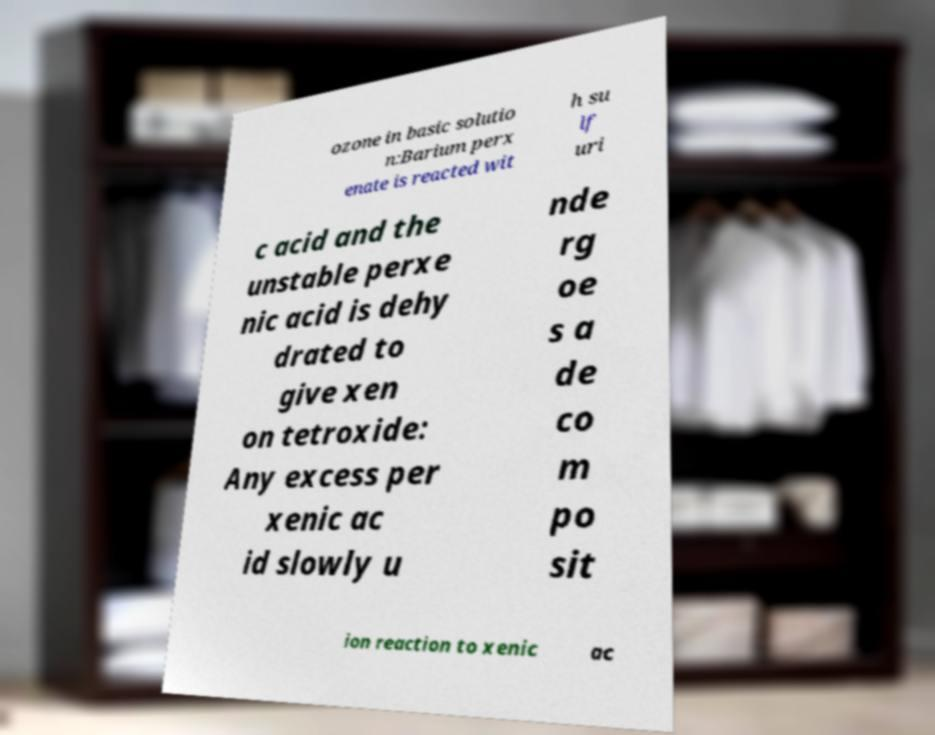Can you accurately transcribe the text from the provided image for me? ozone in basic solutio n:Barium perx enate is reacted wit h su lf uri c acid and the unstable perxe nic acid is dehy drated to give xen on tetroxide: Any excess per xenic ac id slowly u nde rg oe s a de co m po sit ion reaction to xenic ac 